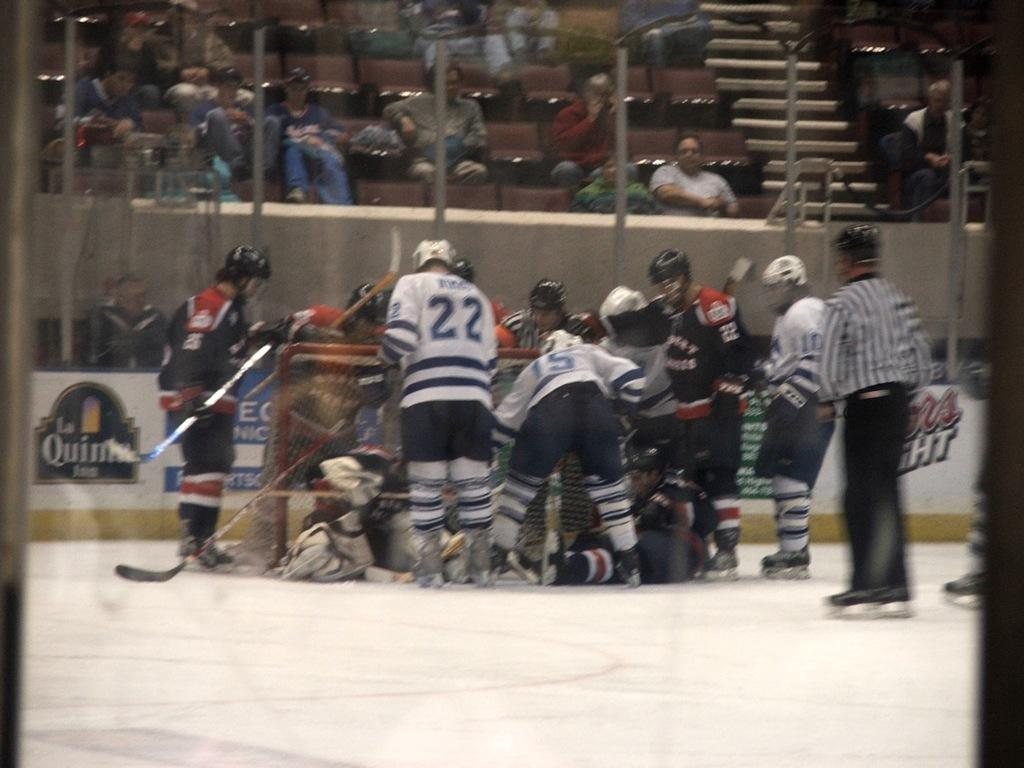What sport are the players in the image participating in? The players in the image are participating in hockey. Where are the hockey players located in the image? The hockey players are in the front of the image. What else can be seen in the image besides the hockey players? There is an audience in the image. What is the audience doing in the image? The audience is sitting and watching the game. Can you see a cub walking around in the image? There is no cub present in the image, and therefore no such activity can be observed. 